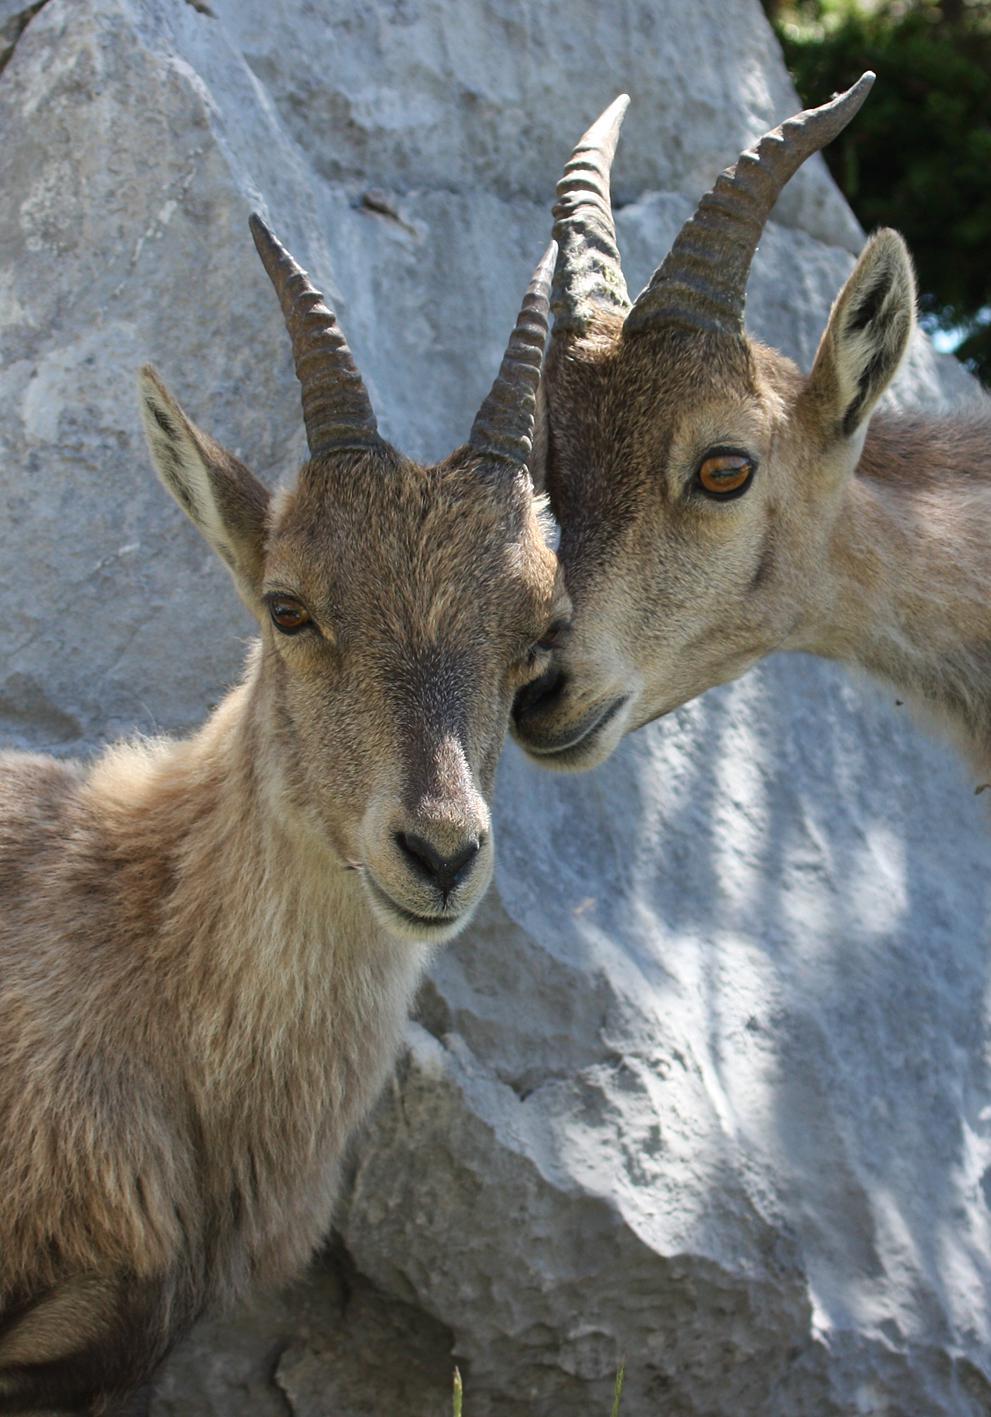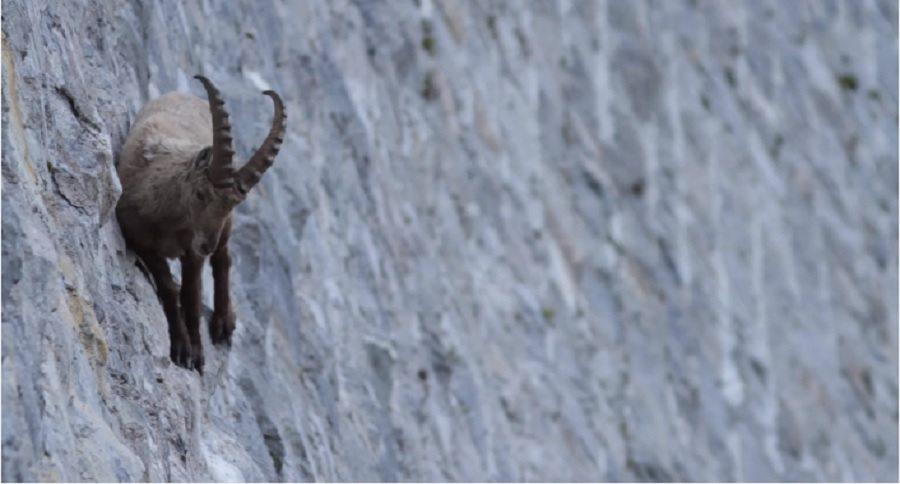The first image is the image on the left, the second image is the image on the right. For the images shown, is this caption "The left and right image contains a total of three goat.." true? Answer yes or no. Yes. The first image is the image on the left, the second image is the image on the right. Evaluate the accuracy of this statement regarding the images: "There is a total of three antelopes.". Is it true? Answer yes or no. Yes. 